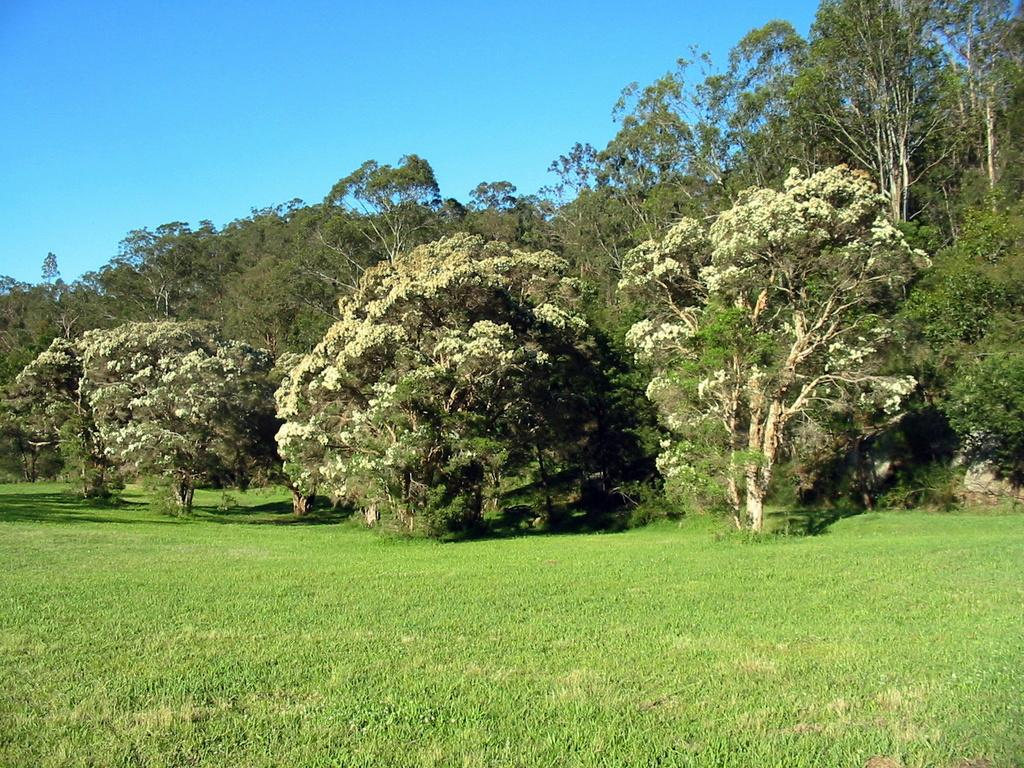What type of vegetation can be seen in the image? There are trees in the image. What else can be seen on the ground in the image? There is grass in the image. What is visible in the background of the image? The sky is visible in the image. How many feathers can be seen on the trees in the image? There are no feathers present on the trees in the image. What type of card is being used by the bears in the image? There are no bears or cards present in the image. 